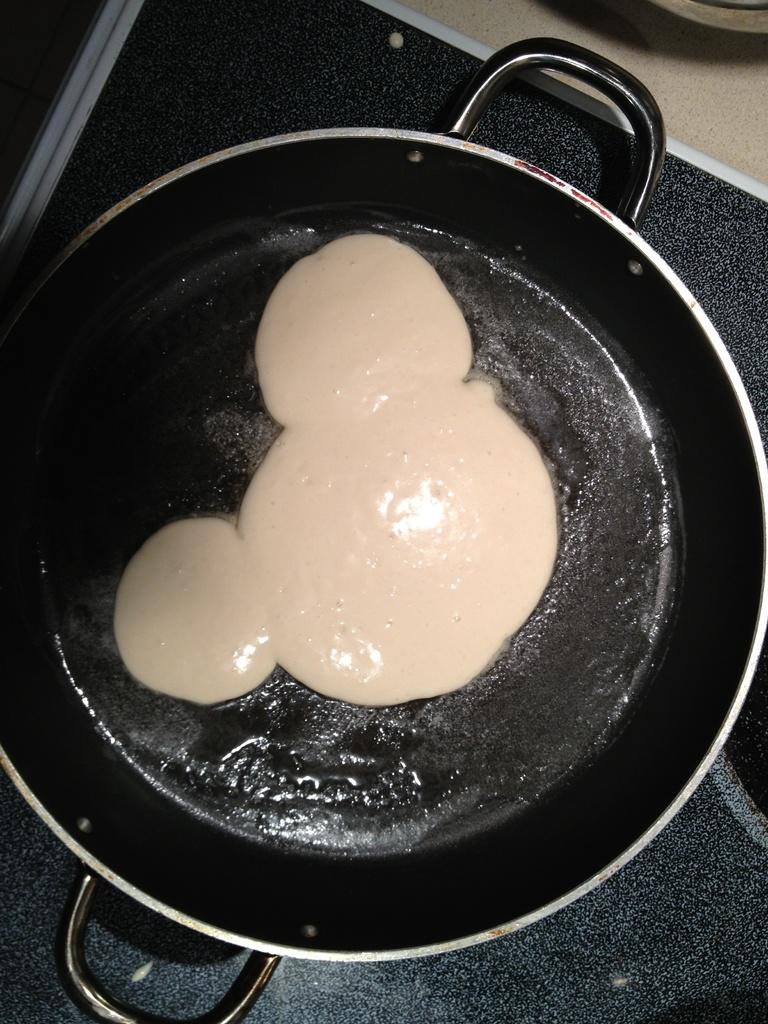What is present in the pan that is visible in the image? There is food in a pan in the image. Can you see any surprise elements in the image? There is no mention of any surprise elements in the image, so it cannot be determined from the provided facts. 